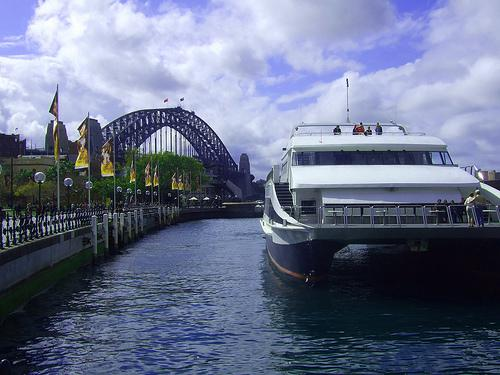Question: where is the boat?
Choices:
A. In water.
B. At the dock.
C. On the shore.
D. Out at sea.
Answer with the letter. Answer: A Question: what time is it?
Choices:
A. Night time.
B. Morning.
C. Evening.
D. Daytime.
Answer with the letter. Answer: D Question: when was the photo taken?
Choices:
A. Morning.
B. Afternoon.
C. Evening.
D. Night time.
Answer with the letter. Answer: B Question: what is in the sky?
Choices:
A. Sun.
B. Birds.
C. Clouds.
D. Rain drops.
Answer with the letter. Answer: C 